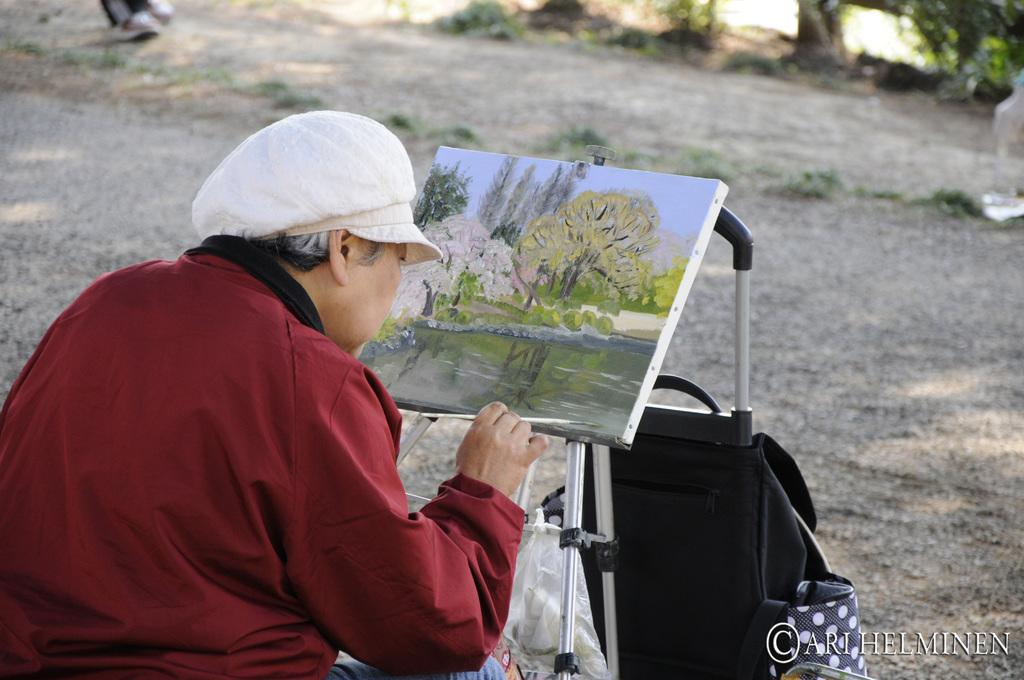What is the main activity being performed by the person in the foreground of the picture? The person in the foreground of the picture is painting. What can be seen in the center of the image? There is a frame and stand in the center of the image. How would you describe the background of the image? The background of the image is blurred, and it includes trees, grass, and soil. What type of bun is being used to hold the person's hair in the image? There is no bun or hair visible in the image; the person is focused on painting. How many legs can be seen on the person in the image? The image only shows the person from the waist up, so it is not possible to determine the number of legs. 